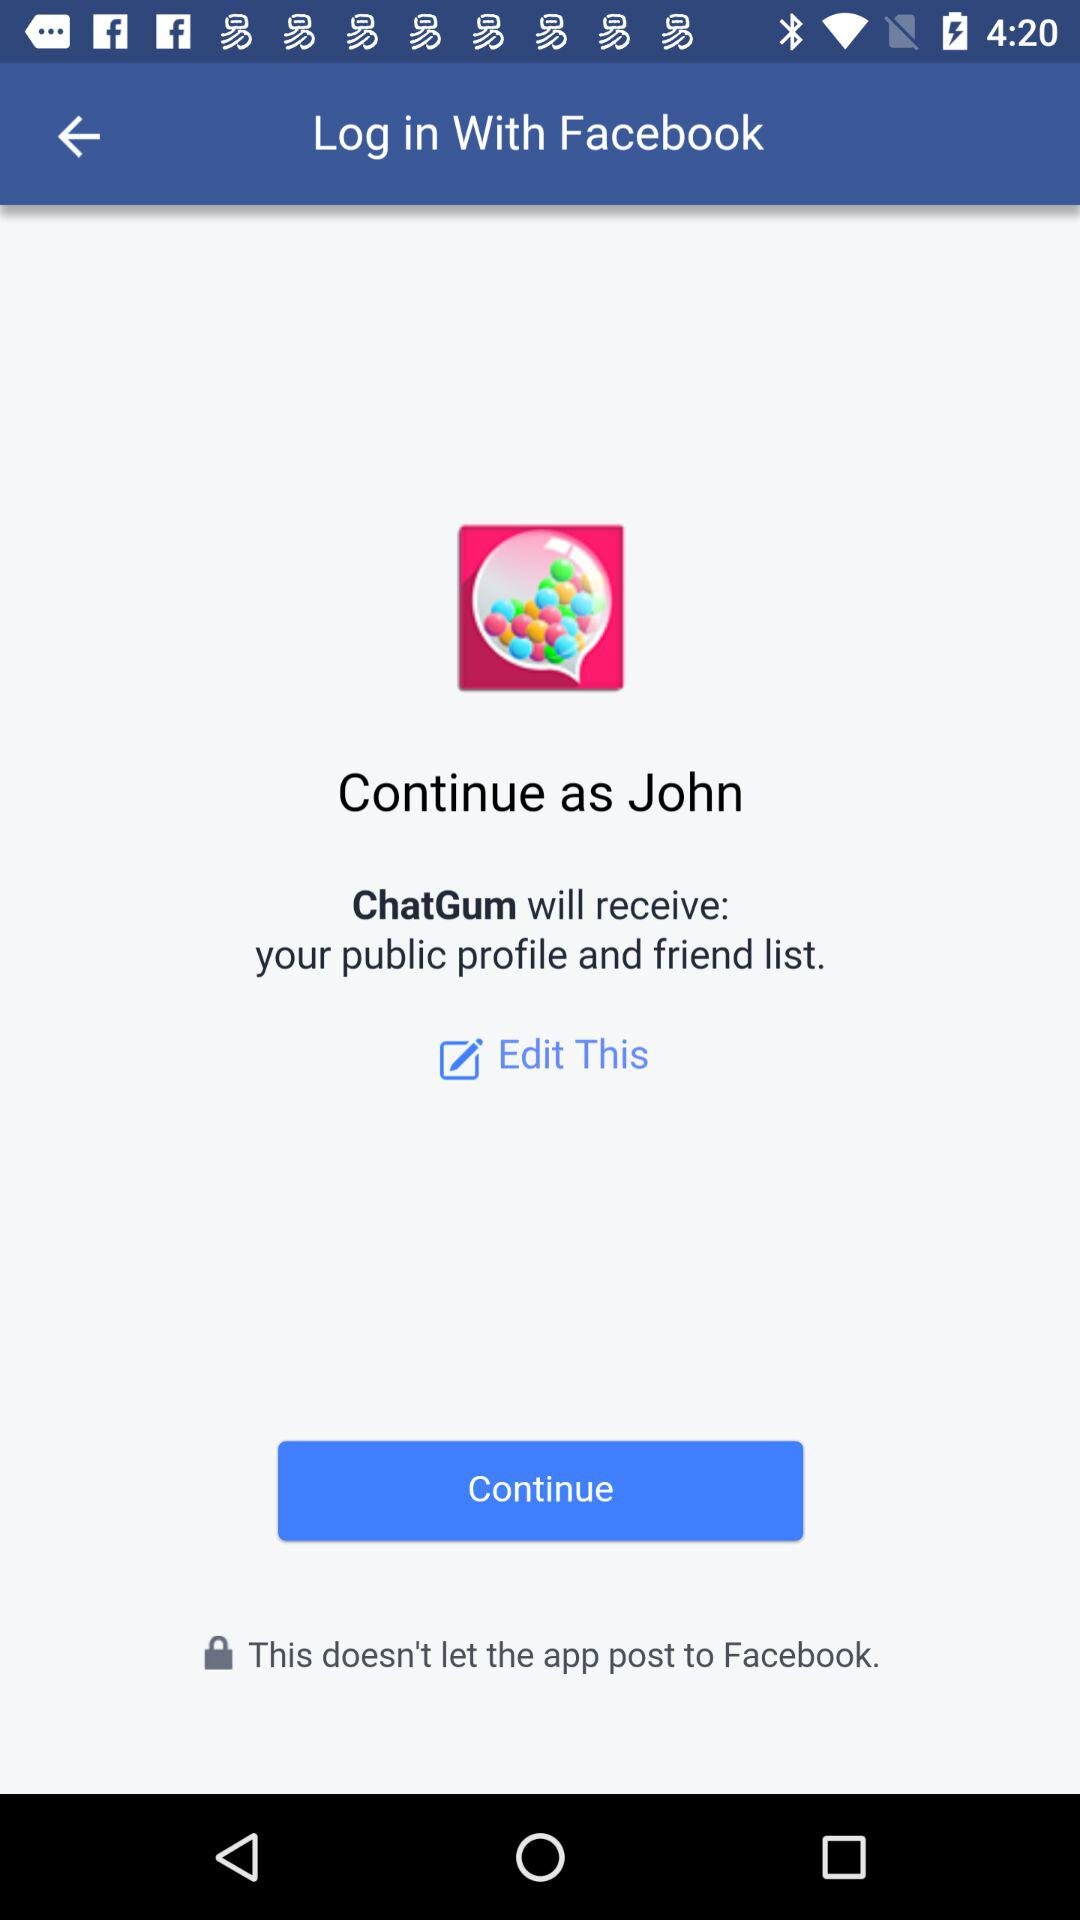What application is asking for permission? The application asking for permission is "ChatGum". 